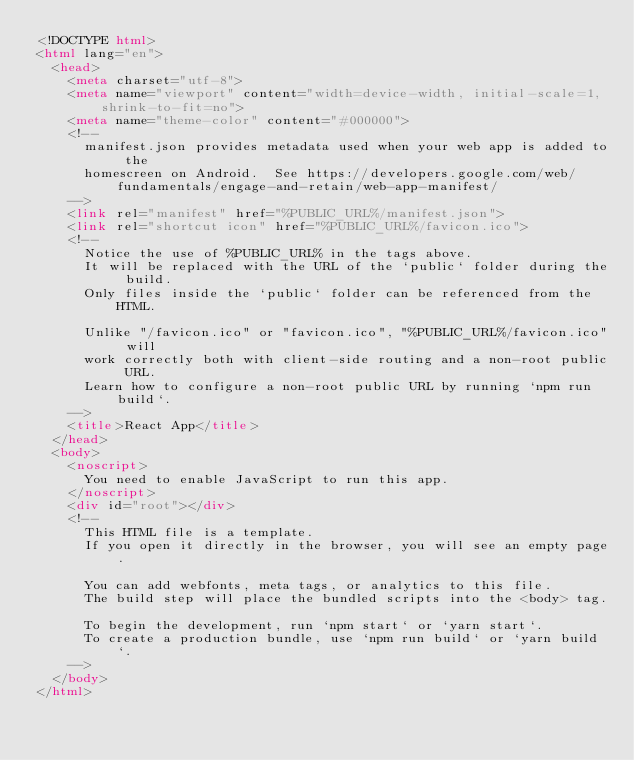Convert code to text. <code><loc_0><loc_0><loc_500><loc_500><_HTML_><!DOCTYPE html>
<html lang="en">
  <head>
    <meta charset="utf-8">
    <meta name="viewport" content="width=device-width, initial-scale=1, shrink-to-fit=no">
    <meta name="theme-color" content="#000000">
    <!--  
      manifest.json provides metadata used when your web app is added to the
      homescreen on Android.  See https://developers.google.com/web/fundamentals/engage-and-retain/web-app-manifest/
    -->
    <link rel="manifest" href="%PUBLIC_URL%/manifest.json">
    <link rel="shortcut icon" href="%PUBLIC_URL%/favicon.ico">
    <!--
      Notice the use of %PUBLIC_URL% in the tags above.
      It will be replaced with the URL of the `public` folder during the build.
      Only files inside the `public` folder can be referenced from the HTML.

      Unlike "/favicon.ico" or "favicon.ico", "%PUBLIC_URL%/favicon.ico" will
      work correctly both with client-side routing and a non-root public URL.
      Learn how to configure a non-root public URL by running `npm run build`.
    -->
    <title>React App</title>
  </head>
  <body>
    <noscript>
      You need to enable JavaScript to run this app.
    </noscript>
    <div id="root"></div>
    <!--
      This HTML file is a template.
      If you open it directly in the browser, you will see an empty page.

      You can add webfonts, meta tags, or analytics to this file.
      The build step will place the bundled scripts into the <body> tag.

      To begin the development, run `npm start` or `yarn start`.
      To create a production bundle, use `npm run build` or `yarn build`.
    -->
  </body>
</html>
</code> 